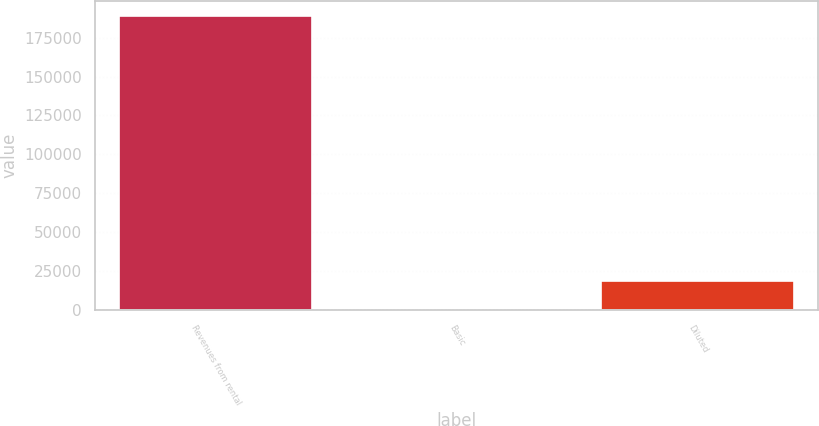Convert chart to OTSL. <chart><loc_0><loc_0><loc_500><loc_500><bar_chart><fcel>Revenues from rental<fcel>Basic<fcel>Diluted<nl><fcel>188794<fcel>0.34<fcel>18879.7<nl></chart> 